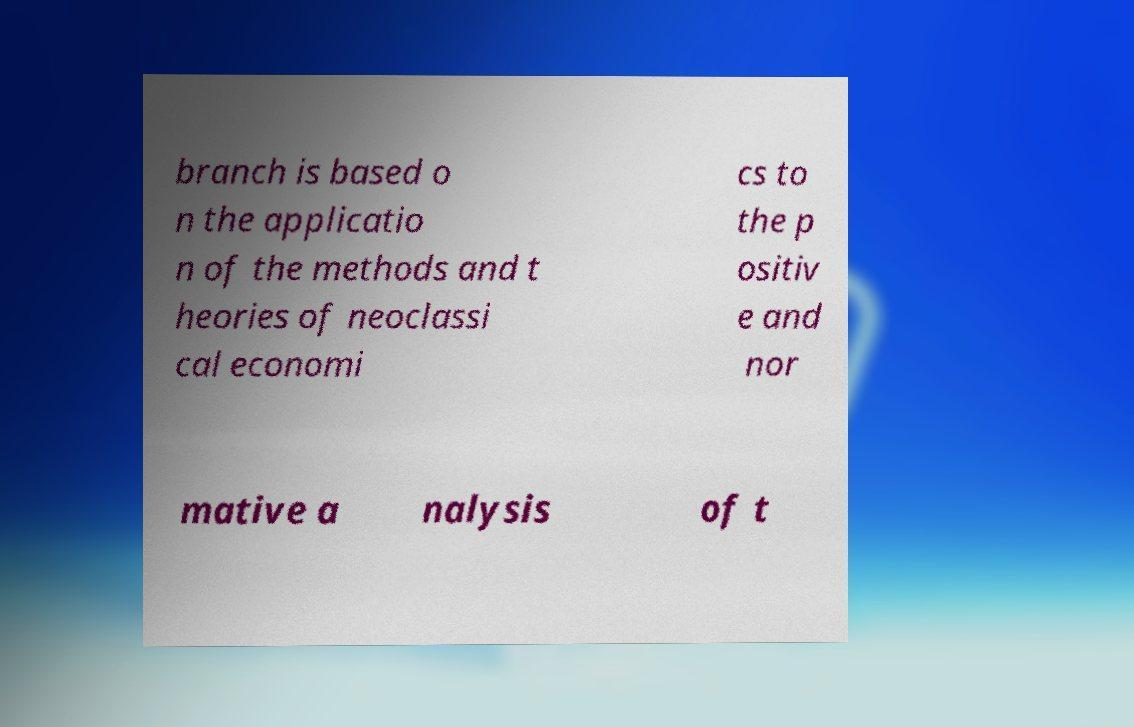Can you read and provide the text displayed in the image?This photo seems to have some interesting text. Can you extract and type it out for me? branch is based o n the applicatio n of the methods and t heories of neoclassi cal economi cs to the p ositiv e and nor mative a nalysis of t 